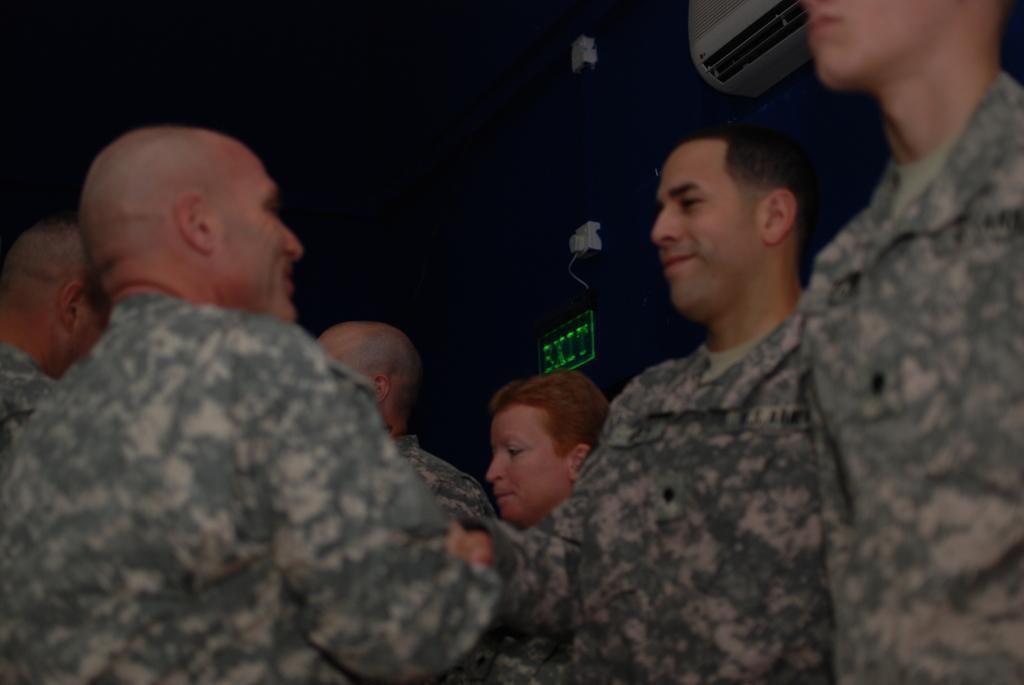Can you describe this image briefly? In this picture we can see few persons. In the background we can see a board and an AC on the wall. 